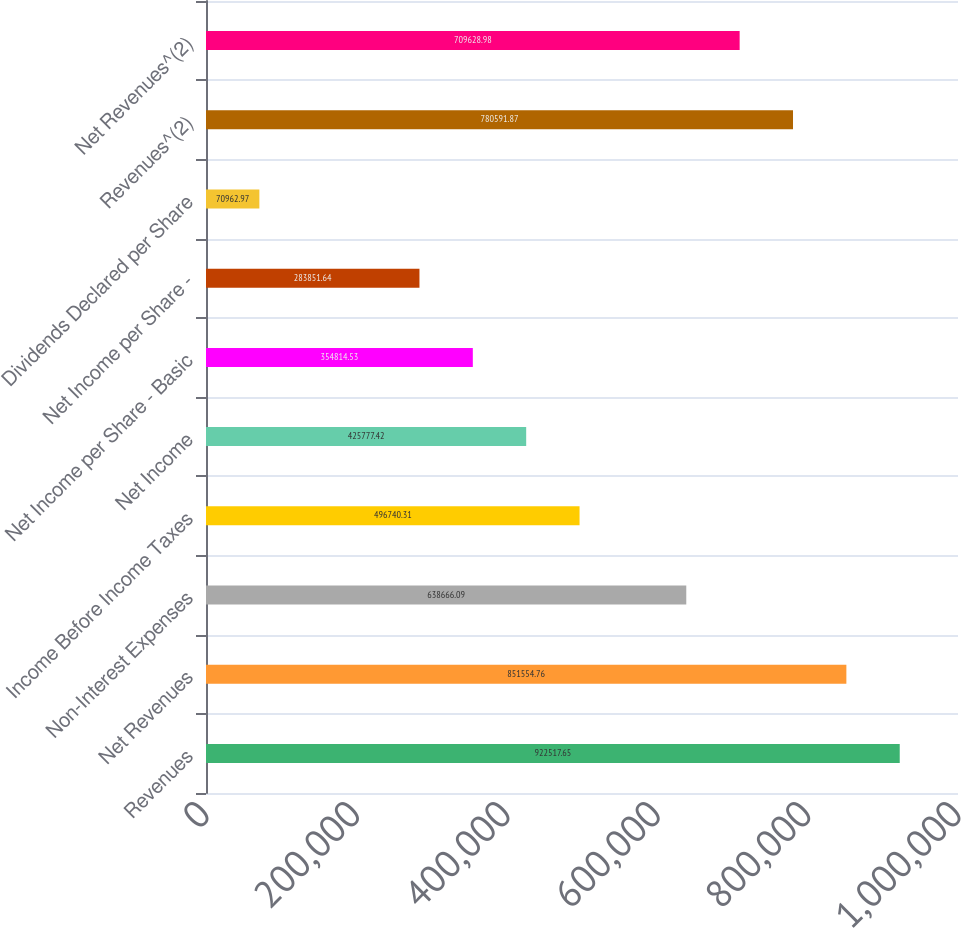Convert chart to OTSL. <chart><loc_0><loc_0><loc_500><loc_500><bar_chart><fcel>Revenues<fcel>Net Revenues<fcel>Non-Interest Expenses<fcel>Income Before Income Taxes<fcel>Net Income<fcel>Net Income per Share - Basic<fcel>Net Income per Share -<fcel>Dividends Declared per Share<fcel>Revenues^(2)<fcel>Net Revenues^(2)<nl><fcel>922518<fcel>851555<fcel>638666<fcel>496740<fcel>425777<fcel>354815<fcel>283852<fcel>70963<fcel>780592<fcel>709629<nl></chart> 